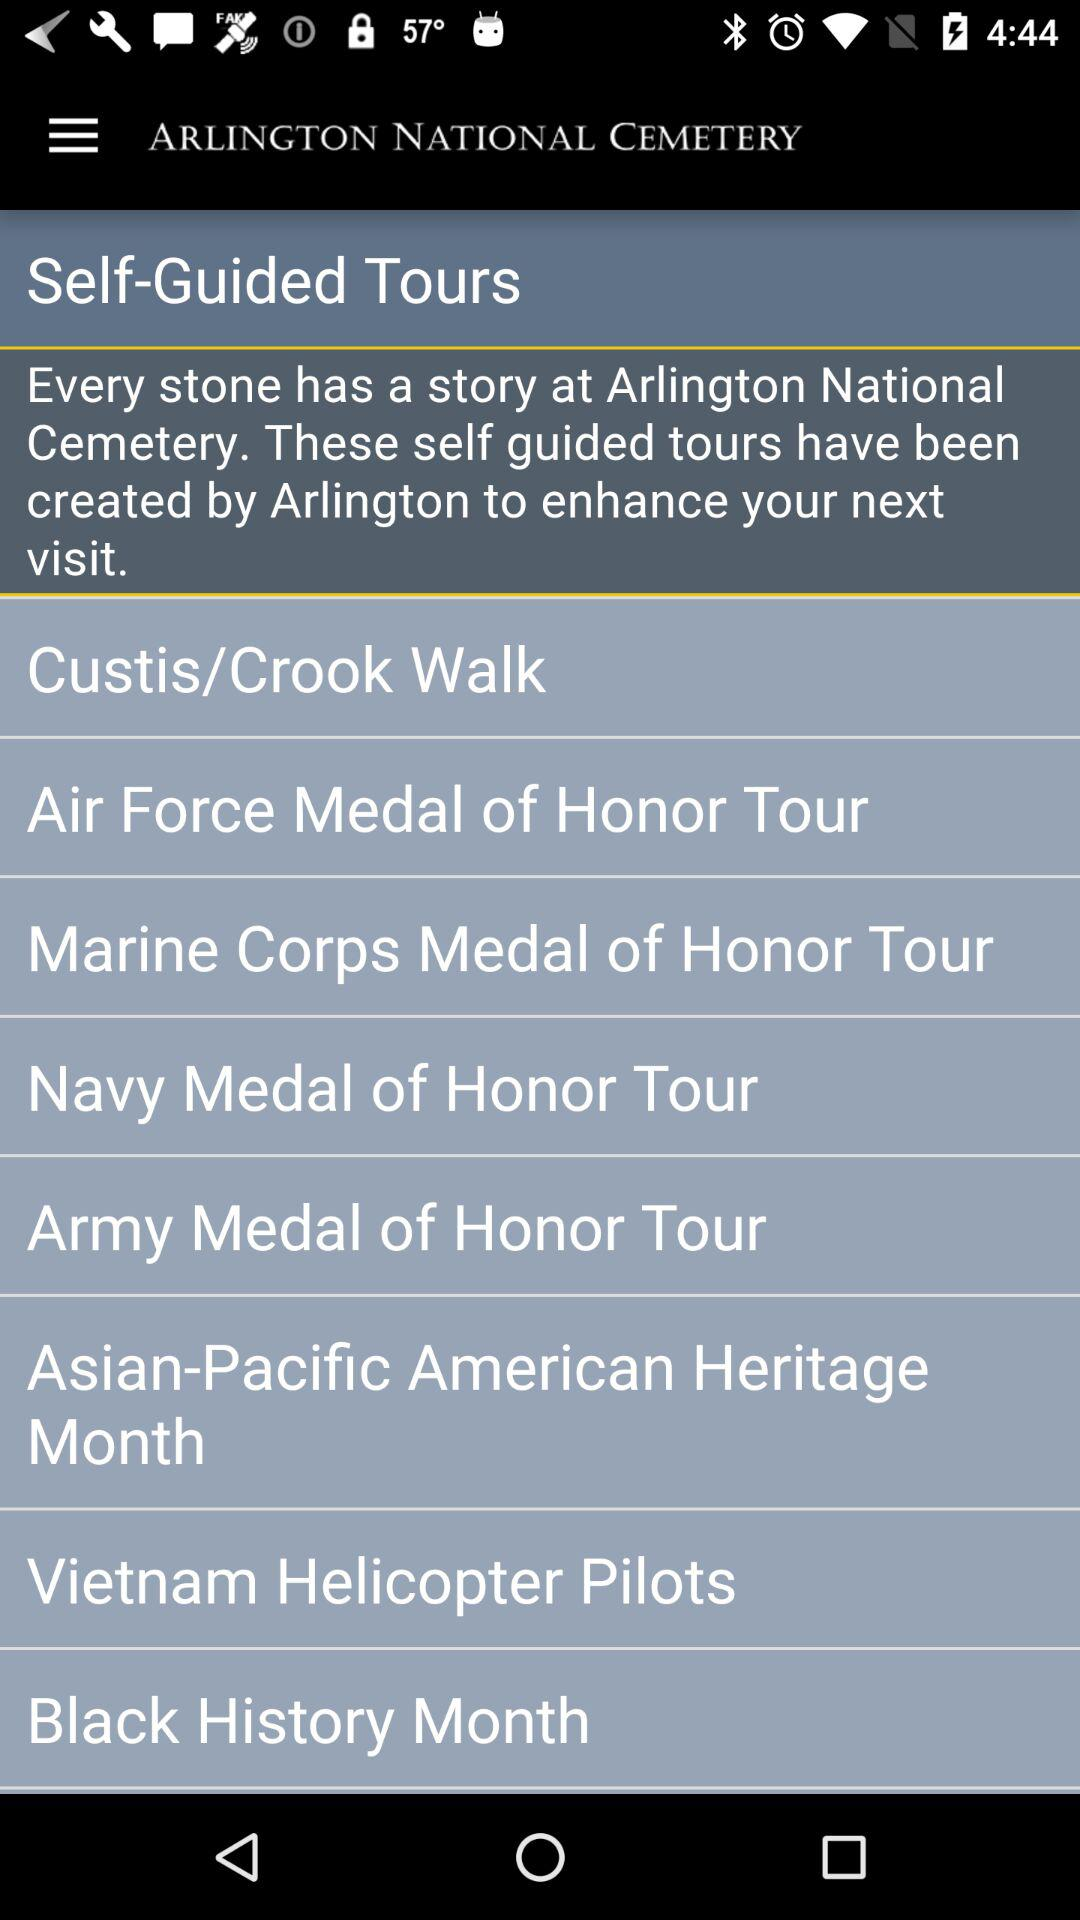What is the name of the application? The name of the application is "ARLINGTON NATIONAL CEMETERY". 